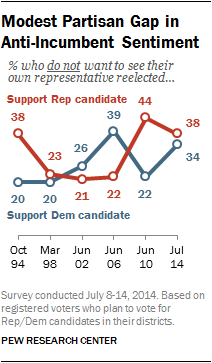Mention a couple of crucial points in this snapshot. The mode of the blue line data is 20. The sentiment of Republican supporters towards incumbents is significantly more anti-incumbent than that of Democratic supporters, with a larger difference in sentiment between the two groups. 